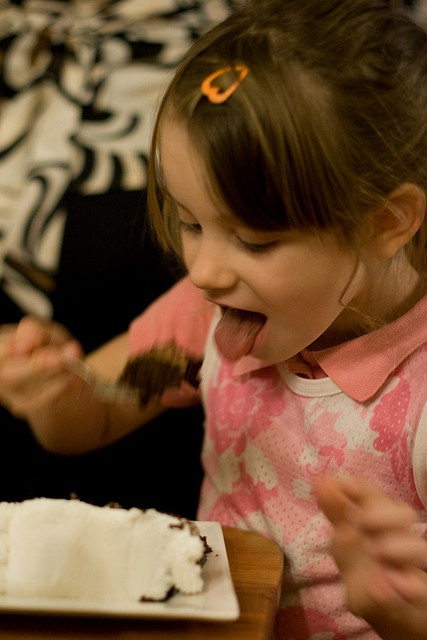Describe the objects in this image and their specific colors. I can see people in gray, black, maroon, brown, and salmon tones, cake in gray and tan tones, and fork in gray, olive, tan, and maroon tones in this image. 